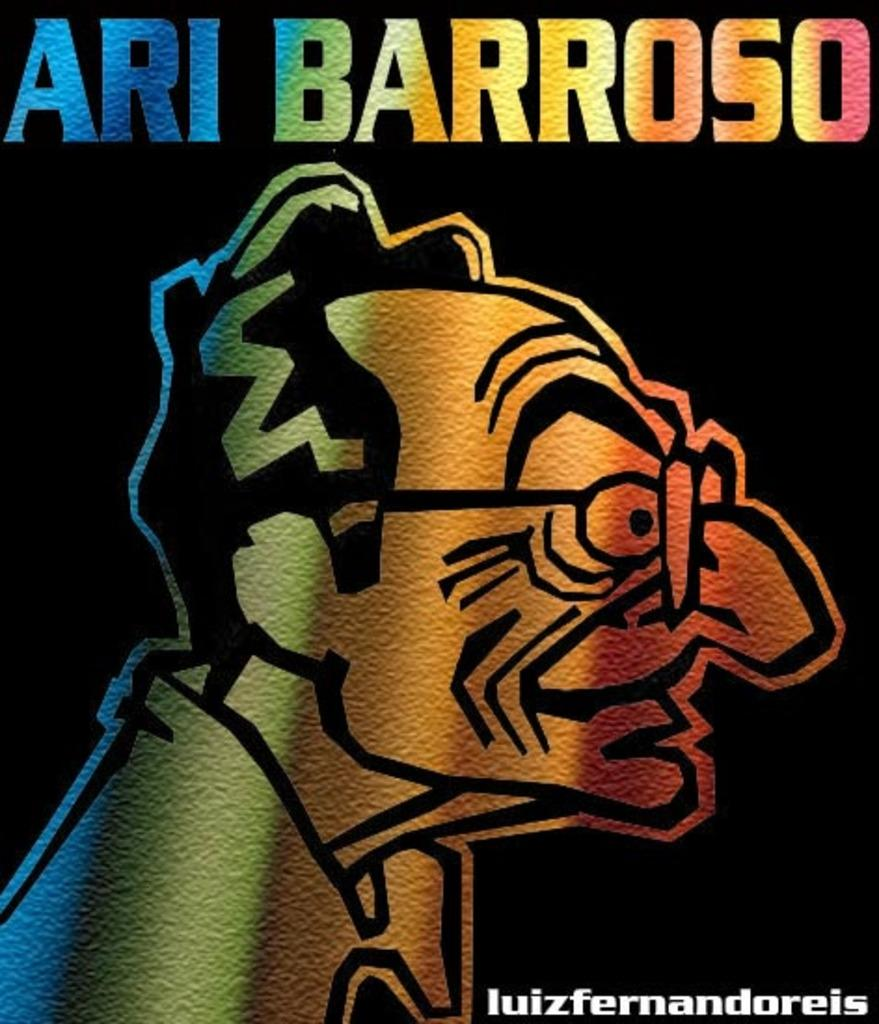<image>
Provide a brief description of the given image. A quirky cartoon of a man with the words Ari Barroso above. 